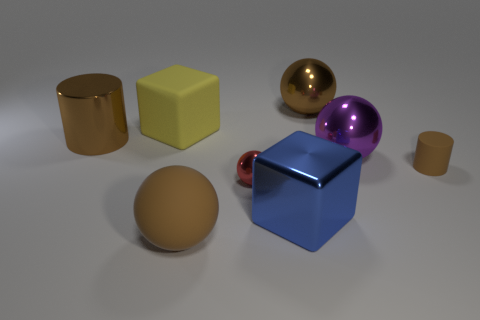Subtract all rubber spheres. How many spheres are left? 3 Add 1 red things. How many objects exist? 9 Subtract all purple balls. How many balls are left? 3 Subtract all cylinders. How many objects are left? 6 Subtract 2 cubes. How many cubes are left? 0 Subtract all green cylinders. Subtract all green blocks. How many cylinders are left? 2 Subtract all brown cylinders. How many blue cubes are left? 1 Subtract all blue cylinders. Subtract all small red things. How many objects are left? 7 Add 6 tiny red shiny spheres. How many tiny red shiny spheres are left? 7 Add 3 red matte blocks. How many red matte blocks exist? 3 